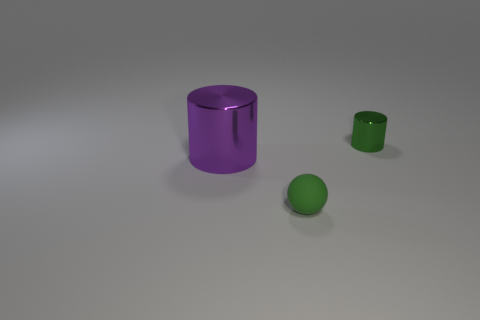What could be the purpose of these objects? The objects seem to be simplistic representations akin to those used in 3D modeling and rendering practices. The purple cylinder may represent a container or a cup, the smaller green cylinder could be a simplified bottle or canister, while the sphere might simply serve as a geometrical form without a specific functional purpose. 